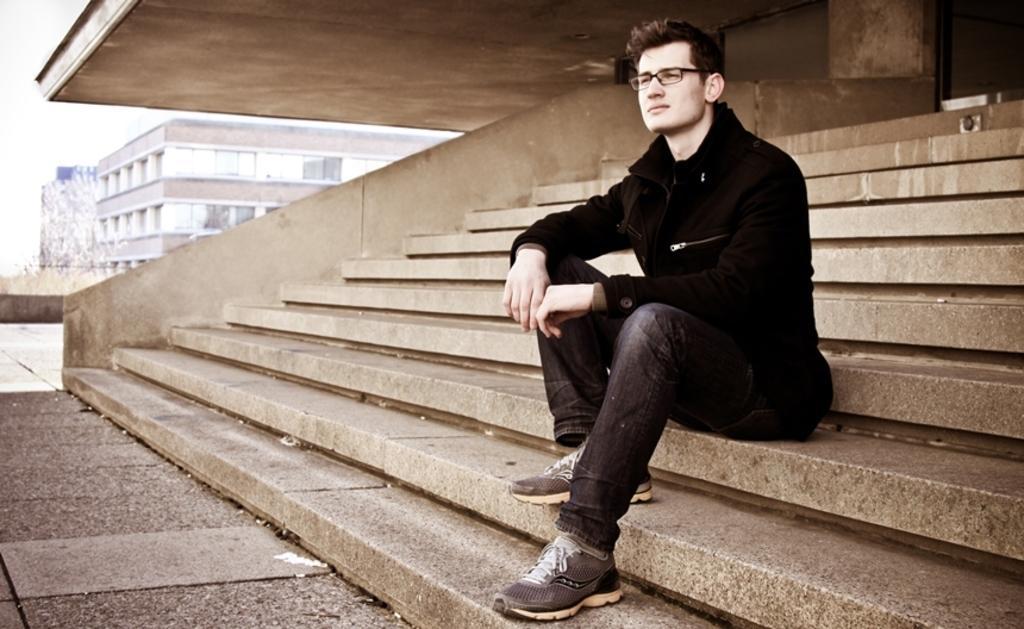Can you describe this image briefly? In this image, we can see a person is sitting on the stairs and wearing glasses. Background we can see wall and railing. On the right side top corner, we can see glass object. Left side background, we can see a building and sky. On the left side bottom of the image, there is a walkway. 